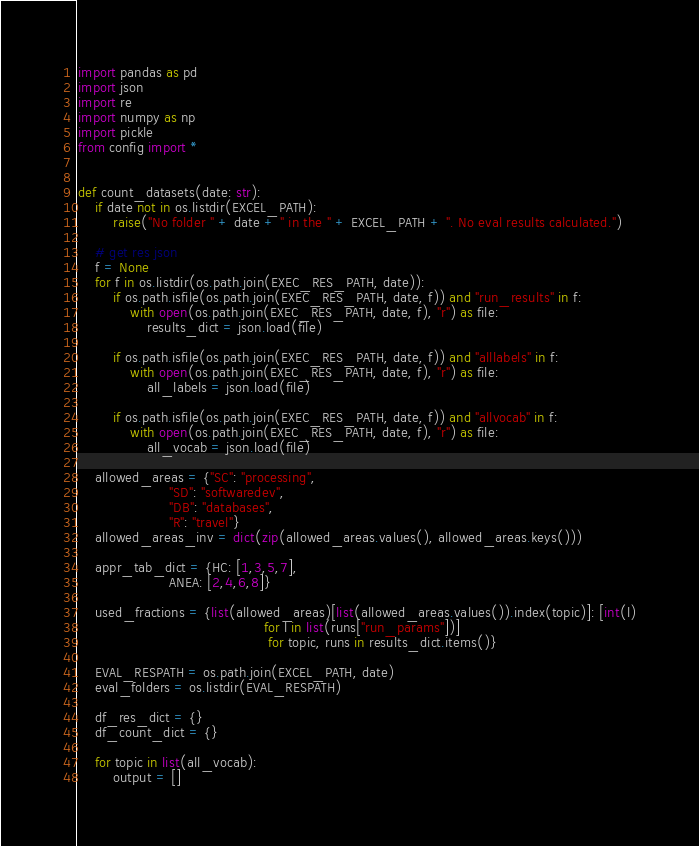<code> <loc_0><loc_0><loc_500><loc_500><_Python_>import pandas as pd
import json
import re
import numpy as np
import pickle
from config import *


def count_datasets(date: str):
    if date not in os.listdir(EXCEL_PATH):
        raise("No folder " + date + " in the " + EXCEL_PATH + ". No eval results calculated.")

    # get res json
    f = None
    for f in os.listdir(os.path.join(EXEC_RES_PATH, date)):
        if os.path.isfile(os.path.join(EXEC_RES_PATH, date, f)) and "run_results" in f:
            with open(os.path.join(EXEC_RES_PATH, date, f), "r") as file:
                results_dict = json.load(file)

        if os.path.isfile(os.path.join(EXEC_RES_PATH, date, f)) and "alllabels" in f:
            with open(os.path.join(EXEC_RES_PATH, date, f), "r") as file:
                all_labels = json.load(file)

        if os.path.isfile(os.path.join(EXEC_RES_PATH, date, f)) and "allvocab" in f:
            with open(os.path.join(EXEC_RES_PATH, date, f), "r") as file:
                all_vocab = json.load(file)

    allowed_areas = {"SC": "processing",
                     "SD": "softwaredev",
                     "DB": "databases",
                     "R": "travel"}
    allowed_areas_inv = dict(zip(allowed_areas.values(), allowed_areas.keys()))

    appr_tab_dict = {HC: [1,3,5,7],
                     ANEA: [2,4,6,8]}

    used_fractions = {list(allowed_areas)[list(allowed_areas.values()).index(topic)]: [int(l)
                                           for l in list(runs["run_params"])]
                                            for topic, runs in results_dict.items()}

    EVAL_RESPATH = os.path.join(EXCEL_PATH, date)
    eval_folders = os.listdir(EVAL_RESPATH)

    df_res_dict = {}
    df_count_dict = {}

    for topic in list(all_vocab):
        output = []
</code> 